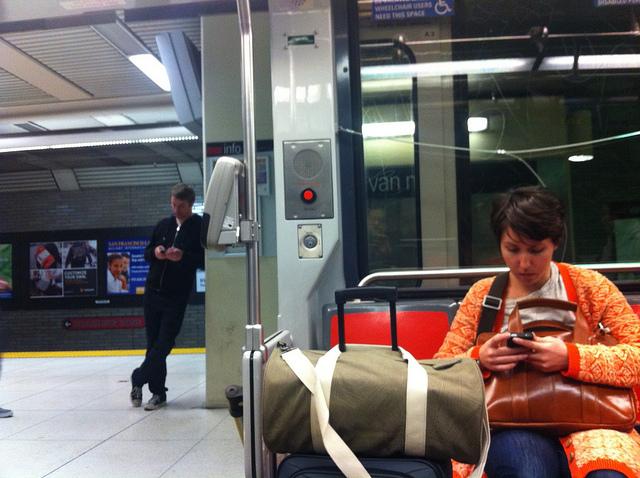What color is the woman's jacket?
Give a very brief answer. Orange. Where is the wheelchair sign?
Write a very short answer. Top. Does the woman have a suitcase?
Give a very brief answer. Yes. 